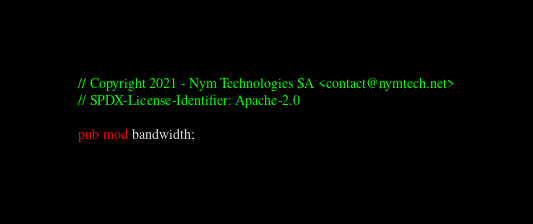<code> <loc_0><loc_0><loc_500><loc_500><_Rust_>// Copyright 2021 - Nym Technologies SA <contact@nymtech.net>
// SPDX-License-Identifier: Apache-2.0

pub mod bandwidth;
</code> 